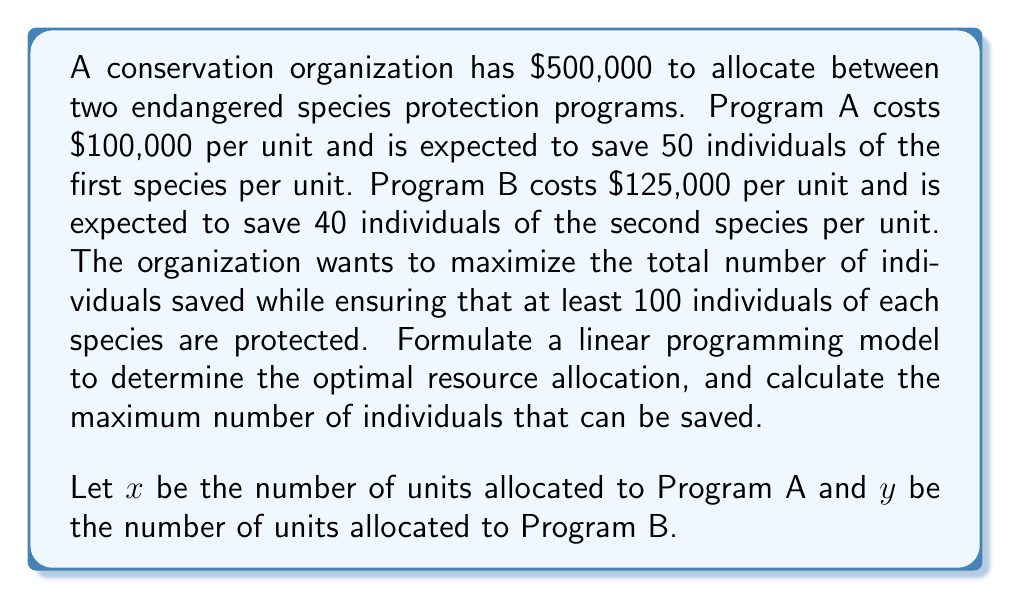Can you solve this math problem? To solve this problem, we'll follow these steps:

1. Formulate the linear programming model
2. Identify the constraints
3. Set up the objective function
4. Solve the linear programming problem

Step 1: Formulate the linear programming model

Decision variables:
$x$ = number of units allocated to Program A
$y$ = number of units allocated to Program B

Step 2: Identify the constraints

Budget constraint:
$100,000x + 125,000y \leq 500,000$

Minimum protection for each species:
$50x \geq 100$ (for the first species)
$40y \geq 100$ (for the second species)

Non-negativity constraints:
$x \geq 0$, $y \geq 0$

Step 3: Set up the objective function

Maximize the total number of individuals saved:
$Z = 50x + 40y$

Step 4: Solve the linear programming problem

Simplify the constraints:
1. $4x + 5y \leq 20$
2. $x \geq 2$
3. $y \geq 2.5$

We can solve this graphically or using the simplex method. In this case, we'll use the graphical method.

Plot the constraints:
[asy]
import geometry;

size(200);
draw((0,0)--(5,0)--(5,4)--(0,4)--cycle);
draw((0,4)--(5,0), dashed);
draw((2,0)--(2,4), dashed);
draw((0,2.5)--(5,2.5), dashed);

label("$x$", (5,0), E);
label("$y$", (0,4), N);
label("$4x+5y=20$", (4,2.5), NE);
label("$x=2$", (2,2), W);
label("$y=2.5$", (1,2.5), W);

dot((2,2.5));
dot((2,3.2));
dot((3,2.5));

label("A", (2,2.5), SW);
label("B", (2,3.2), NW);
label("C", (3,2.5), SE);
[/asy]

The feasible region is the area bounded by the constraints. The optimal solution will be at one of the corner points: A(2, 2.5), B(2, 3.2), or C(3, 2.5).

Evaluate the objective function at each point:
A: $Z = 50(2) + 40(2.5) = 200$
B: $Z = 50(2) + 40(3.2) = 228$
C: $Z = 50(3) + 40(2.5) = 250$

The maximum value occurs at point C(3, 2.5).
Answer: The optimal resource allocation is to assign 3 units to Program A and 2.5 units to Program B. This will result in a maximum of 250 individuals saved. 